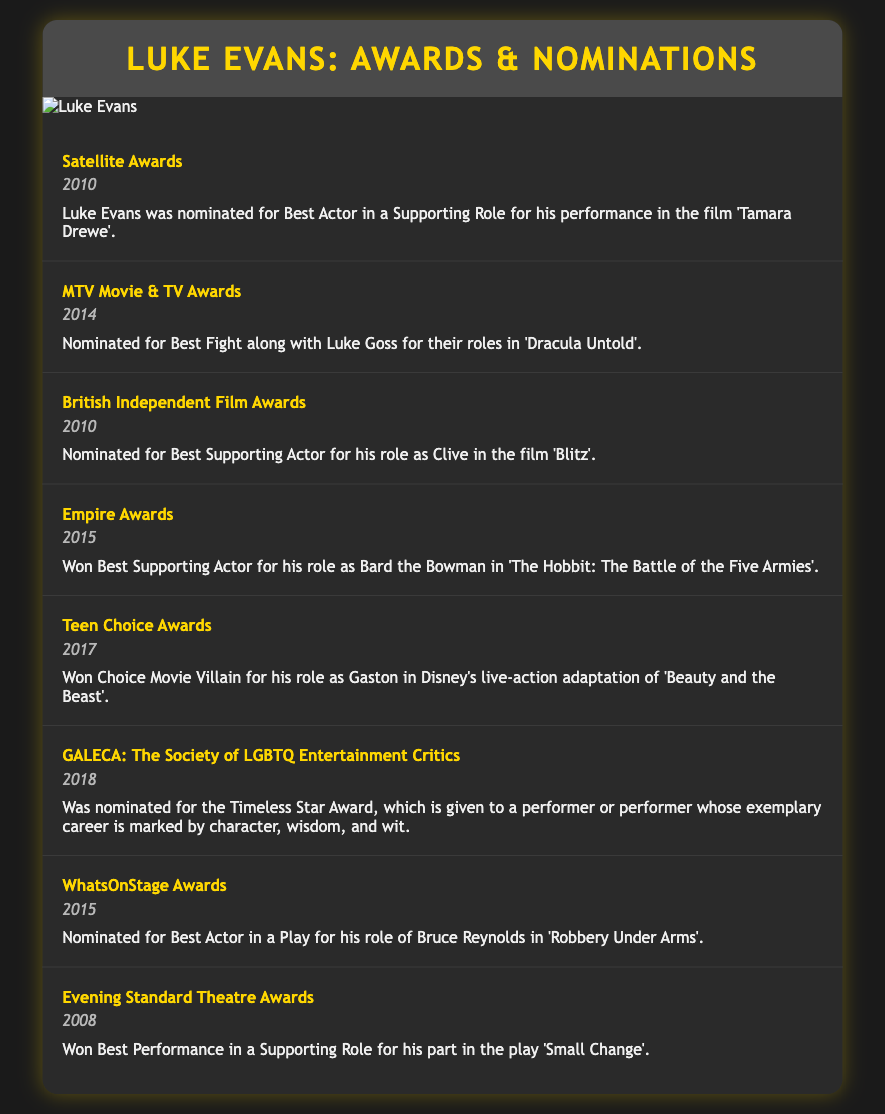What award did Luke Evans win in 2015? Luke Evans won Best Supporting Actor for his role as Bard the Bowman in "The Hobbit: The Battle of the Five Armies".
Answer: Best Supporting Actor In which year was Luke Evans nominated for the Teen Choice Awards? Luke Evans was nominated for the Teen Choice Awards in 2017 for his role as Gaston.
Answer: 2017 What performance earned Luke Evans a nomination at the British Independent Film Awards? Luke Evans was nominated for Best Supporting Actor for his role as Clive in the film "Blitz".
Answer: Best Supporting Actor in "Blitz" Which award did Luke Evans win for his role in "Beauty and the Beast"? Luke Evans won Choice Movie Villain for his role as Gaston in Disney's live-action adaptation of "Beauty and the Beast".
Answer: Choice Movie Villain How many awards did Luke Evans win at the Evening Standard Theatre Awards? Luke Evans won one award at the Evening Standard Theatre Awards for his performance in "Small Change".
Answer: One 